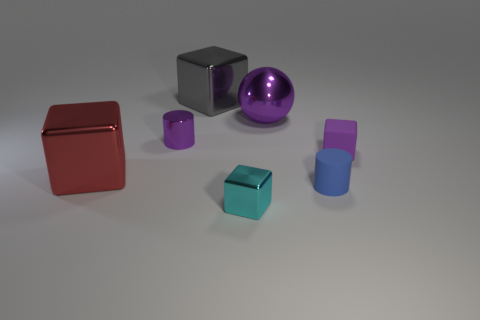Subtract 1 blocks. How many blocks are left? 3 Add 1 large blue rubber cylinders. How many objects exist? 8 Subtract all spheres. How many objects are left? 6 Add 6 gray blocks. How many gray blocks are left? 7 Add 6 small cyan objects. How many small cyan objects exist? 7 Subtract 0 gray spheres. How many objects are left? 7 Subtract all small purple blocks. Subtract all purple cubes. How many objects are left? 5 